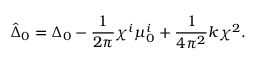<formula> <loc_0><loc_0><loc_500><loc_500>\hat { \Delta } _ { 0 } = \Delta _ { 0 } - \frac { 1 } { 2 \pi } \chi ^ { i } \mu _ { 0 } ^ { i } + \frac { 1 } { 4 \pi ^ { 2 } } k \chi ^ { 2 } .</formula> 